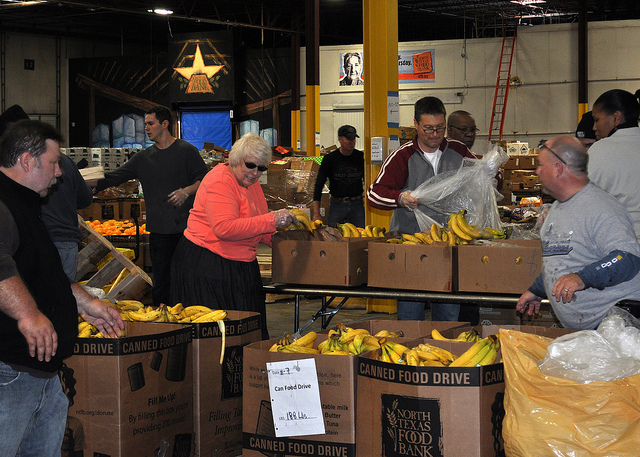Identify and read out the text in this image. CANNED FOOD DRIVE NORTH TEXAS DRIVE CANNED CAN DRIVE FOOD CANNED BANK FOOD 